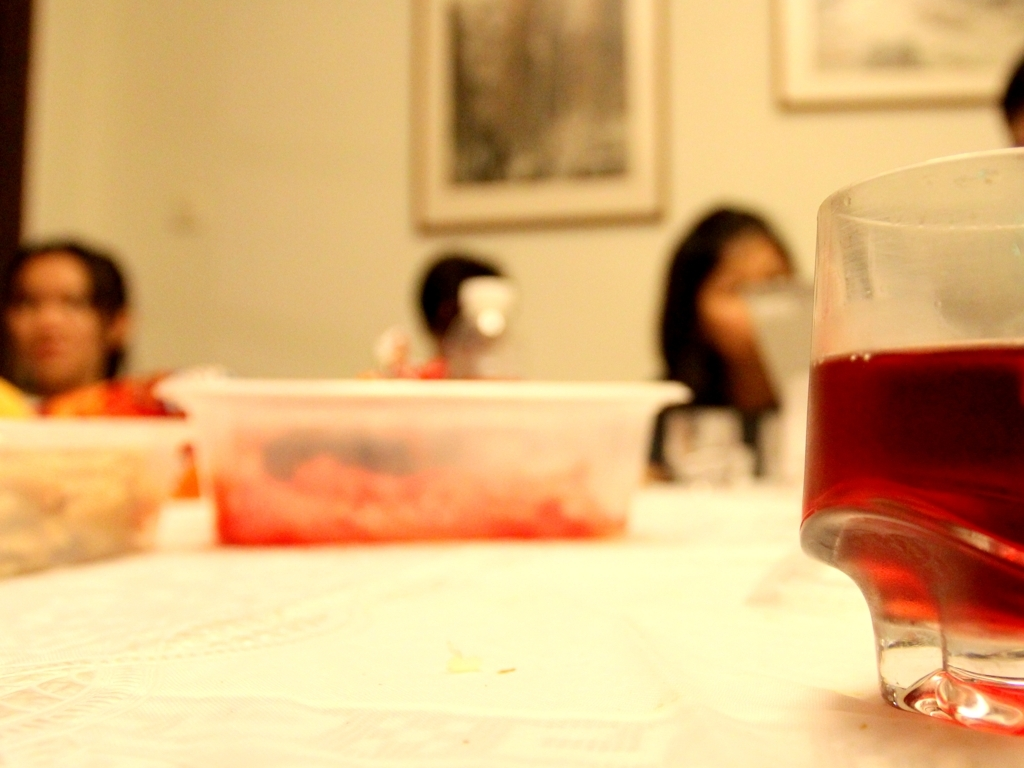What is happening in this image? The image appears to capture a casual and intimate gathering, possibly a dinner, as indicated by the presence of food containers and the glass filled with a dark-colored beverage, set on a table with a white tablecloth. Why might the photographer choose to blur the people in the background? A photographer might intentionally blur the background to highlight a particular element of the image, create a sense of atmosphere, or to put the emphasis on the mood rather than the identity of the individuals. It's a way to paint a scene that feels personal and engages the viewer's curiosity about the specifics of the social interaction. 